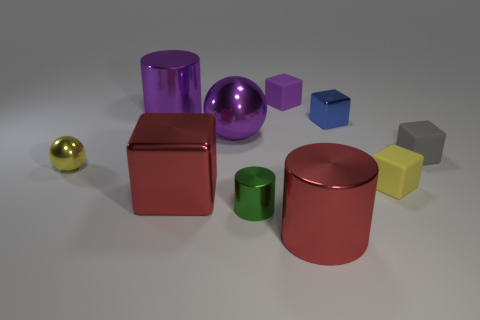The large thing that is the same color as the large sphere is what shape?
Ensure brevity in your answer.  Cylinder. Is the cylinder that is behind the small gray thing made of the same material as the small gray thing?
Make the answer very short. No. Is there a big shiny cylinder?
Give a very brief answer. Yes. The purple ball that is made of the same material as the blue thing is what size?
Offer a terse response. Large. Are there any big cylinders that have the same color as the large sphere?
Make the answer very short. Yes. Is the color of the large metal cylinder behind the tiny yellow rubber thing the same as the ball behind the small metal sphere?
Provide a succinct answer. Yes. There is a matte object that is the same color as the big sphere; what is its size?
Your response must be concise. Small. Are there any large red balls that have the same material as the gray cube?
Offer a terse response. No. What color is the big ball?
Provide a succinct answer. Purple. What is the size of the metal cube that is behind the yellow object left of the metallic cylinder that is behind the small metallic cube?
Ensure brevity in your answer.  Small. 